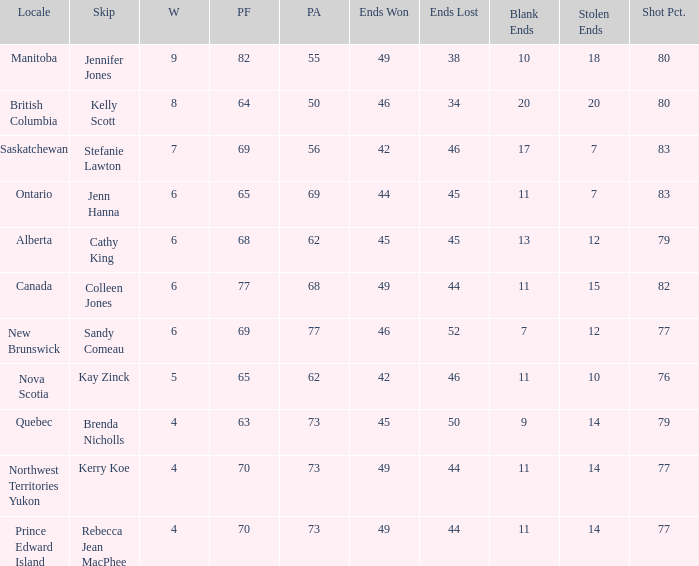What is the PA when the skip is Colleen Jones? 68.0. 